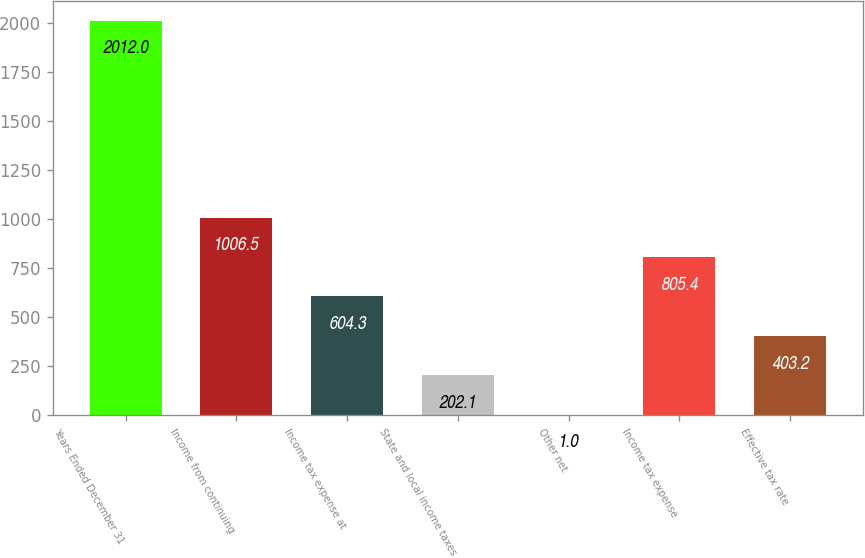<chart> <loc_0><loc_0><loc_500><loc_500><bar_chart><fcel>Years Ended December 31<fcel>Income from continuing<fcel>Income tax expense at<fcel>State and local income taxes<fcel>Other net<fcel>Income tax expense<fcel>Effective tax rate<nl><fcel>2012<fcel>1006.5<fcel>604.3<fcel>202.1<fcel>1<fcel>805.4<fcel>403.2<nl></chart> 